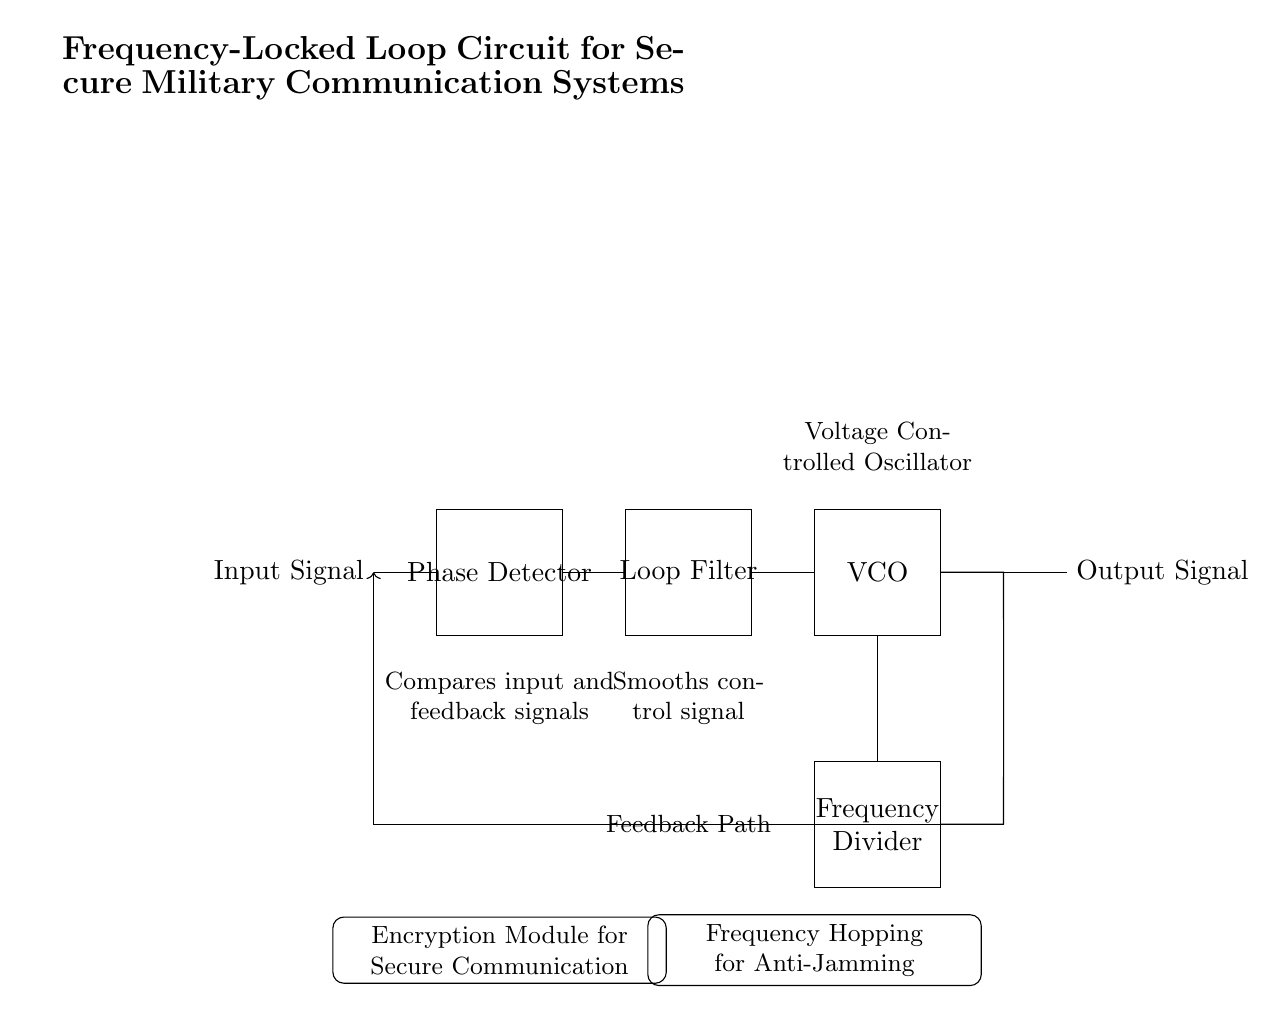What is the main purpose of the phase detector? The phase detector compares the input signal to the feedback signal, determining the phase difference between them. This is essential for the operation of the frequency-locked loop as it adjusts the output frequency to match the input.
Answer: Compares input and feedback signals What follows the phase detector in the circuit? The loop filter follows the phase detector; this component smooths out the control signal produced by the phase detector, ensuring stable frequency control for the voltage-controlled oscillator.
Answer: Loop Filter What component adjusts the output frequency in response to the control signal? The voltage-controlled oscillator (VCO) adjusts its output frequency based on the voltage control signal it receives from the loop filter, allowing for dynamic frequency modulation.
Answer: VCO What is the function of the frequency divider? The frequency divider takes the output from the VCO and reduces its frequency, providing the correct feedback signal level for the phase detector to maintain synchronization.
Answer: Frequency Divider How does the encryption module enhance security? The encryption module encodes the output signal, ensuring that even if the signal is intercepted, it remains confidential and secure for military communication purposes.
Answer: Encryption Module for Secure Communication What feature helps to prevent jamming in this circuit? Frequency hopping is implemented to change the signal frequency rapidly, making it difficult for jammers to target the communication link effectively, thus enhancing the robustness of military communication.
Answer: Frequency Hopping for Anti-Jamming 